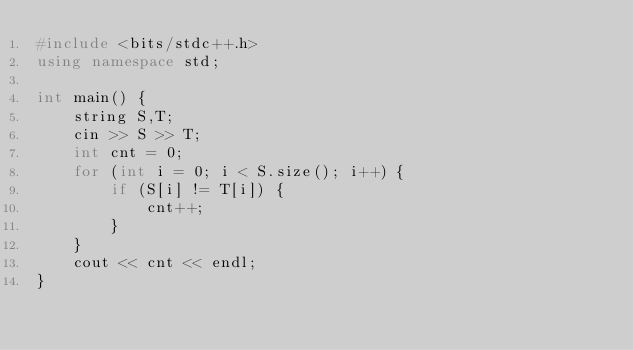<code> <loc_0><loc_0><loc_500><loc_500><_C++_>#include <bits/stdc++.h>
using namespace std;

int main() {
    string S,T;
    cin >> S >> T;
    int cnt = 0;
    for (int i = 0; i < S.size(); i++) {
        if (S[i] != T[i]) {
            cnt++;
        }
    }
    cout << cnt << endl;
}
</code> 